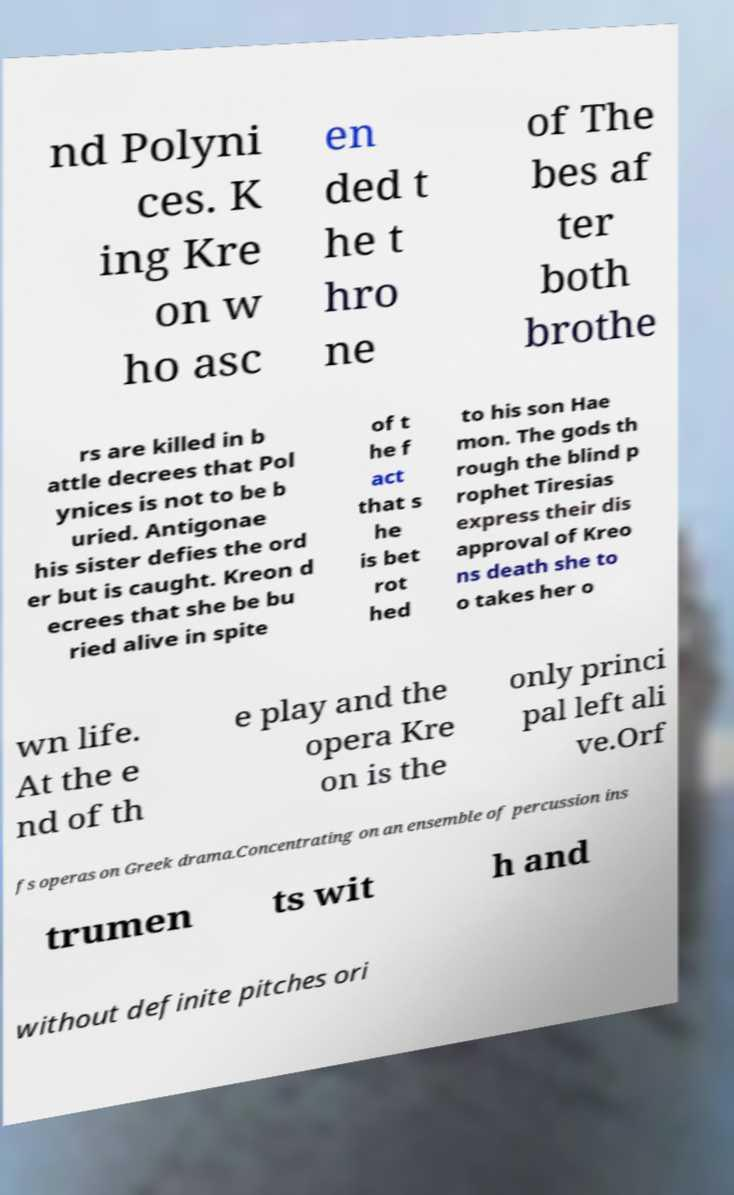For documentation purposes, I need the text within this image transcribed. Could you provide that? nd Polyni ces. K ing Kre on w ho asc en ded t he t hro ne of The bes af ter both brothe rs are killed in b attle decrees that Pol ynices is not to be b uried. Antigonae his sister defies the ord er but is caught. Kreon d ecrees that she be bu ried alive in spite of t he f act that s he is bet rot hed to his son Hae mon. The gods th rough the blind p rophet Tiresias express their dis approval of Kreo ns death she to o takes her o wn life. At the e nd of th e play and the opera Kre on is the only princi pal left ali ve.Orf fs operas on Greek drama.Concentrating on an ensemble of percussion ins trumen ts wit h and without definite pitches ori 